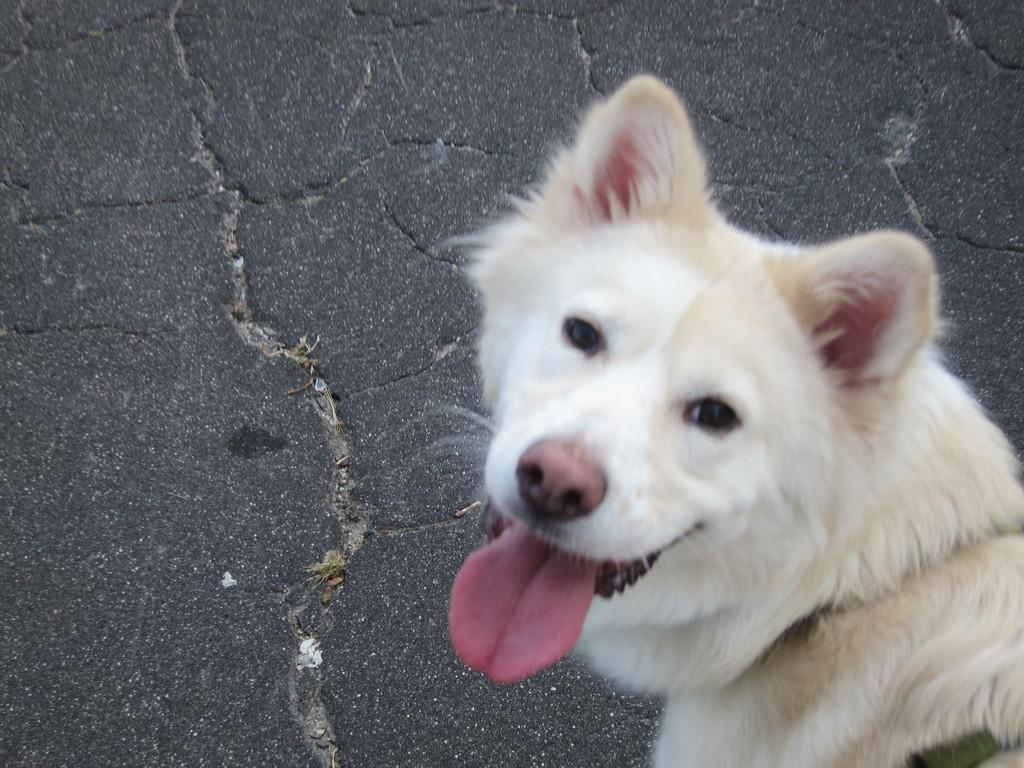What type of animal is in the image? There is a white dog in the image. What is the dog doing in the image? The dog is looking at the camera. What part of the dog's body is visible in the image? The dog's tongue is visible. What can be seen in the background of the image? There is a road in the background of the image. What is the color of the road in the image? The road appears to be black in color. How many icicles are hanging from the dog's ears in the image? There are no icicles present in the image; it features a white dog with its tongue visible. 